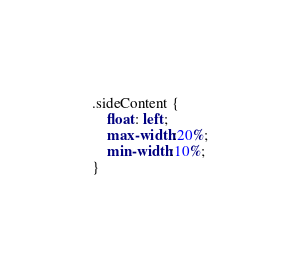<code> <loc_0><loc_0><loc_500><loc_500><_CSS_>.sideContent {
    float: left;
    max-width:20%;
    min-width:10%;
}</code> 